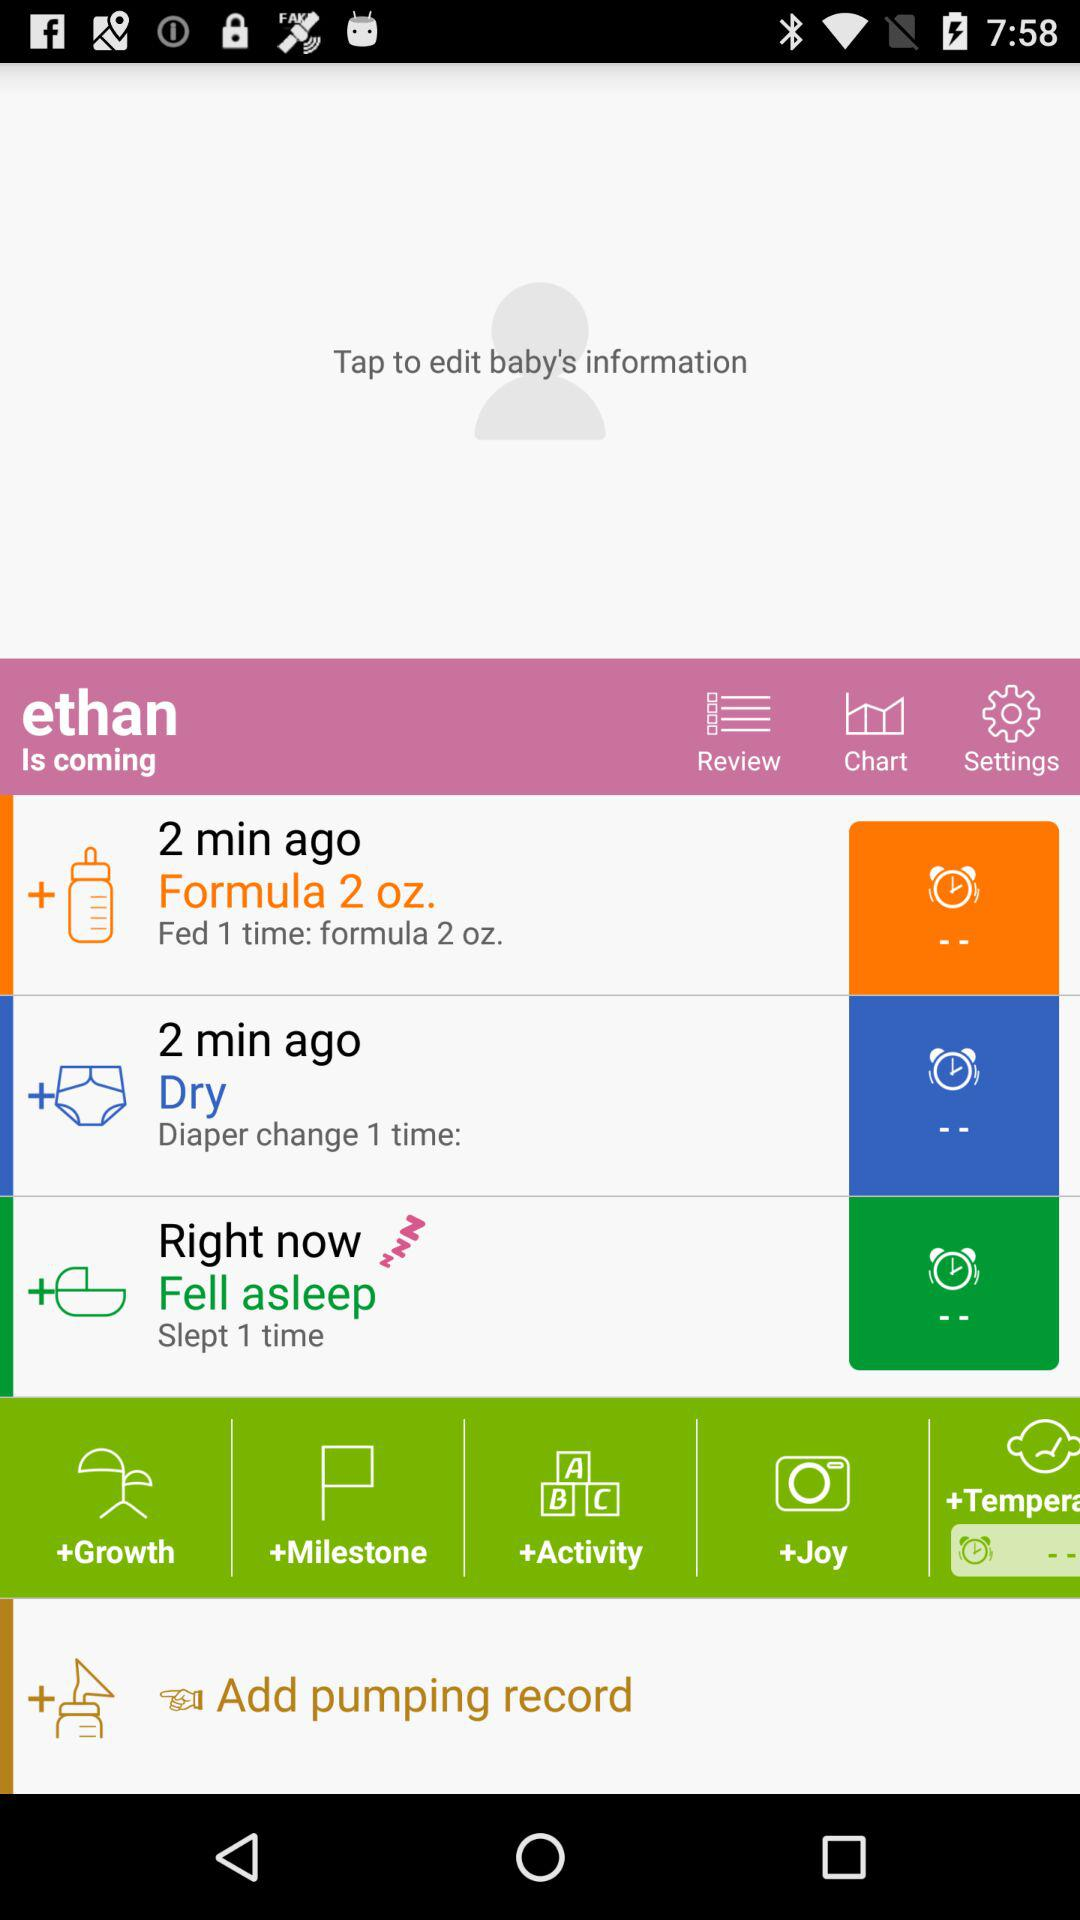What is the procedure 2 minutes ago?
When the provided information is insufficient, respond with <no answer>. <no answer> 